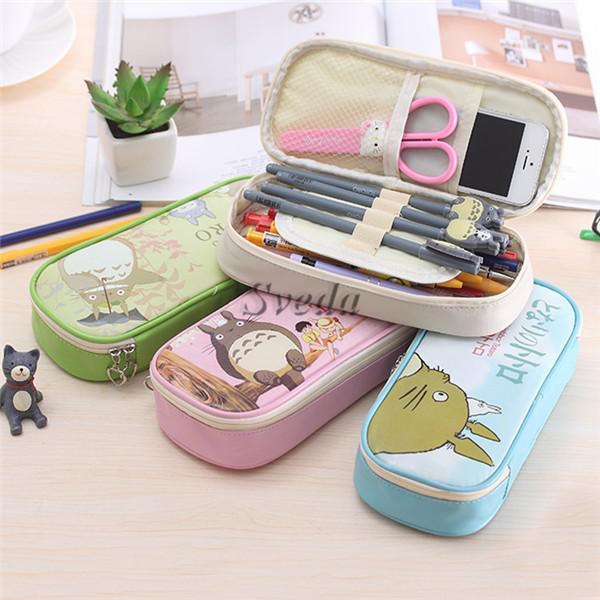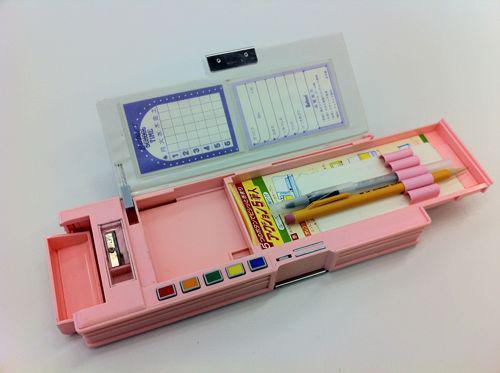The first image is the image on the left, the second image is the image on the right. Examine the images to the left and right. Is the description "The left image contains only closed containers, the right has one open with multiple pencils inside." accurate? Answer yes or no. No. The first image is the image on the left, the second image is the image on the right. Evaluate the accuracy of this statement regarding the images: "box shaped pencil holders are folded open". Is it true? Answer yes or no. Yes. 